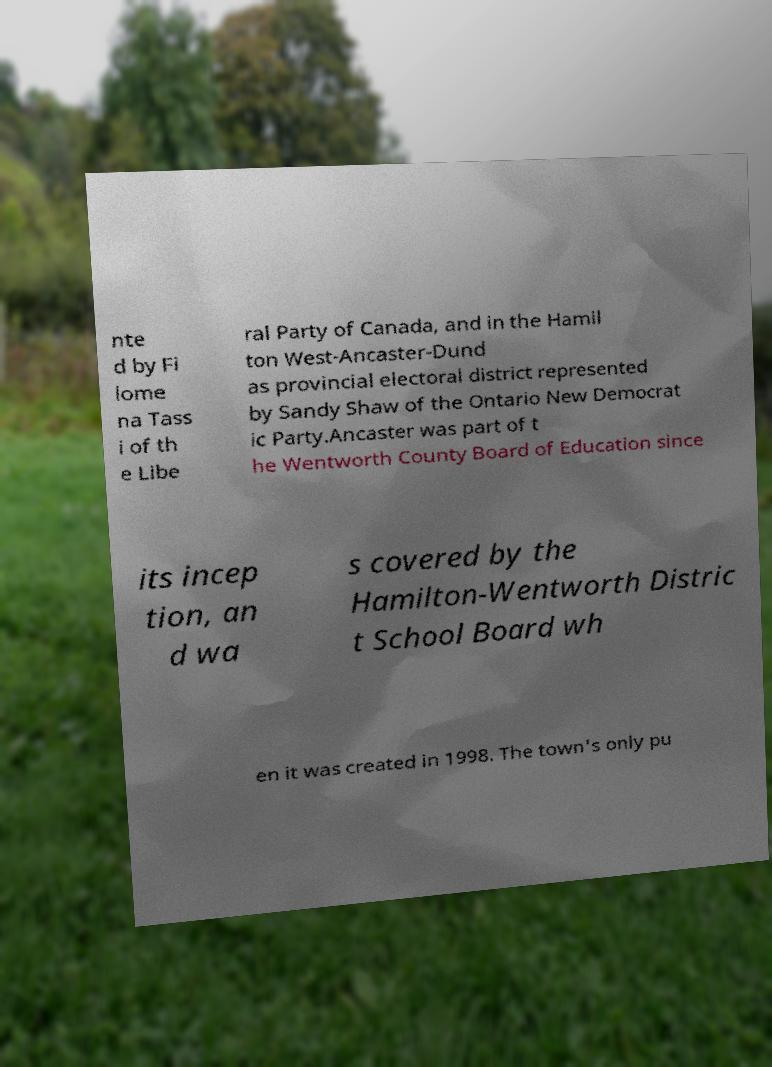Could you extract and type out the text from this image? nte d by Fi lome na Tass i of th e Libe ral Party of Canada, and in the Hamil ton West-Ancaster-Dund as provincial electoral district represented by Sandy Shaw of the Ontario New Democrat ic Party.Ancaster was part of t he Wentworth County Board of Education since its incep tion, an d wa s covered by the Hamilton-Wentworth Distric t School Board wh en it was created in 1998. The town's only pu 